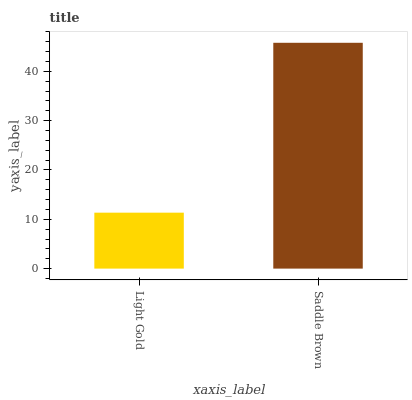Is Saddle Brown the minimum?
Answer yes or no. No. Is Saddle Brown greater than Light Gold?
Answer yes or no. Yes. Is Light Gold less than Saddle Brown?
Answer yes or no. Yes. Is Light Gold greater than Saddle Brown?
Answer yes or no. No. Is Saddle Brown less than Light Gold?
Answer yes or no. No. Is Saddle Brown the high median?
Answer yes or no. Yes. Is Light Gold the low median?
Answer yes or no. Yes. Is Light Gold the high median?
Answer yes or no. No. Is Saddle Brown the low median?
Answer yes or no. No. 